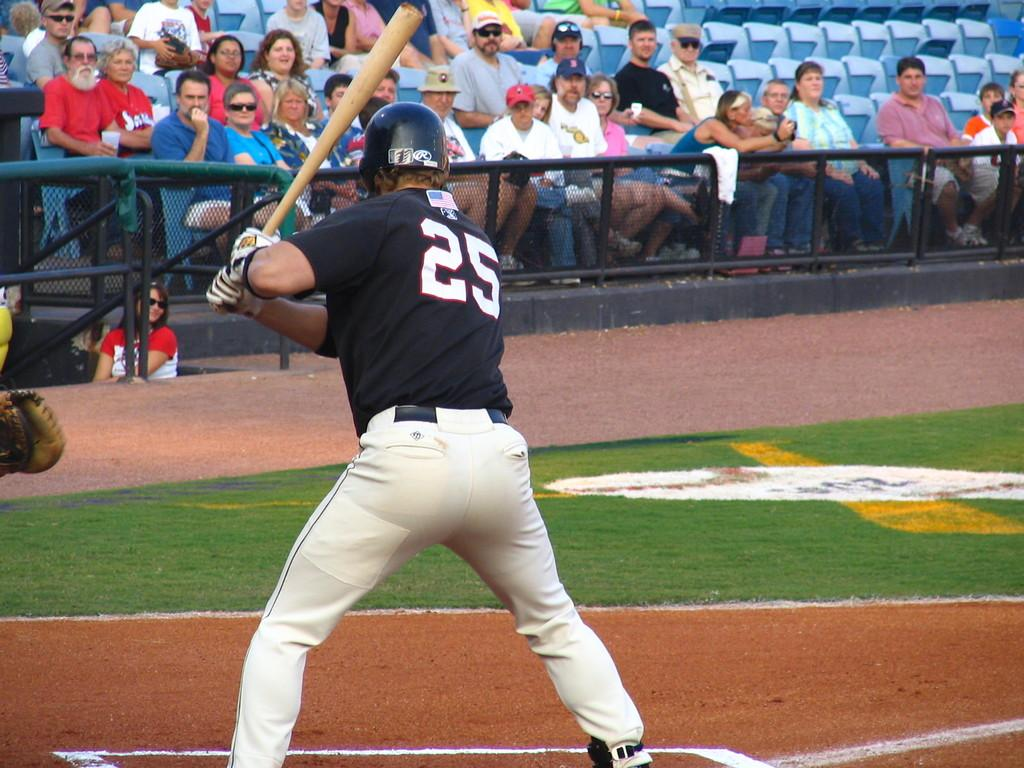<image>
Give a short and clear explanation of the subsequent image. Number 25 at bat on the field waiting for a pitch. 